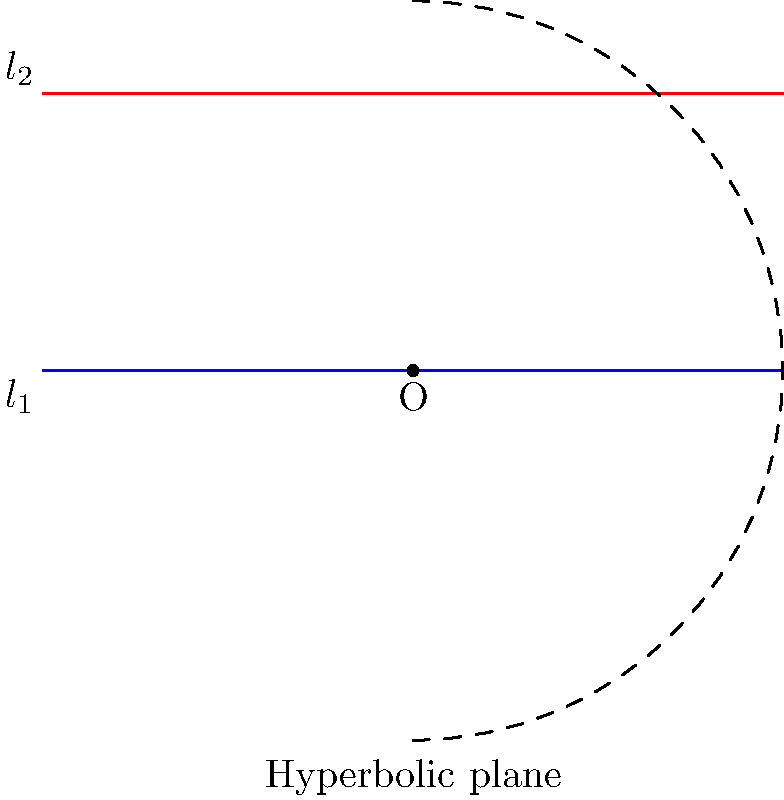In a hyperbolic plane, two parallel lines $l_1$ and $l_2$ are shown. As these lines extend towards infinity, what happens to the distance between them, and how does this relate to the curvature of the hyperbolic plane? To answer this question, let's consider the properties of hyperbolic geometry:

1. In hyperbolic geometry, the curvature of the plane is constant and negative.

2. This negative curvature causes parallel lines to behave differently than in Euclidean geometry:
   a. They diverge from each other as they extend towards infinity.
   b. The distance between them increases exponentially.

3. The relationship between curvature and parallel lines:
   a. The more negative the curvature, the faster the parallel lines diverge.
   b. This is because the space is "expanding" more rapidly in areas of higher negative curvature.

4. In the diagram:
   - $l_1$ (blue) and $l_2$ (red) are parallel lines.
   - As they extend towards the edge of the hyperbolic plane (represented by the dashed circle), they appear to diverge.

5. This divergence is a direct result of the negative curvature:
   - The space between the lines "expands" as you move away from the center.
   - This expansion is uniform across the plane due to constant curvature.

6. Contrast with Euclidean geometry:
   - In Euclidean geometry (flat plane), parallel lines maintain a constant distance.
   - The difference in behavior highlights the unique properties of hyperbolic geometry.

Therefore, as the parallel lines extend towards infinity in a hyperbolic plane, the distance between them increases exponentially, directly reflecting the constant negative curvature of the plane.
Answer: The distance between parallel lines increases exponentially, reflecting the constant negative curvature of the hyperbolic plane. 